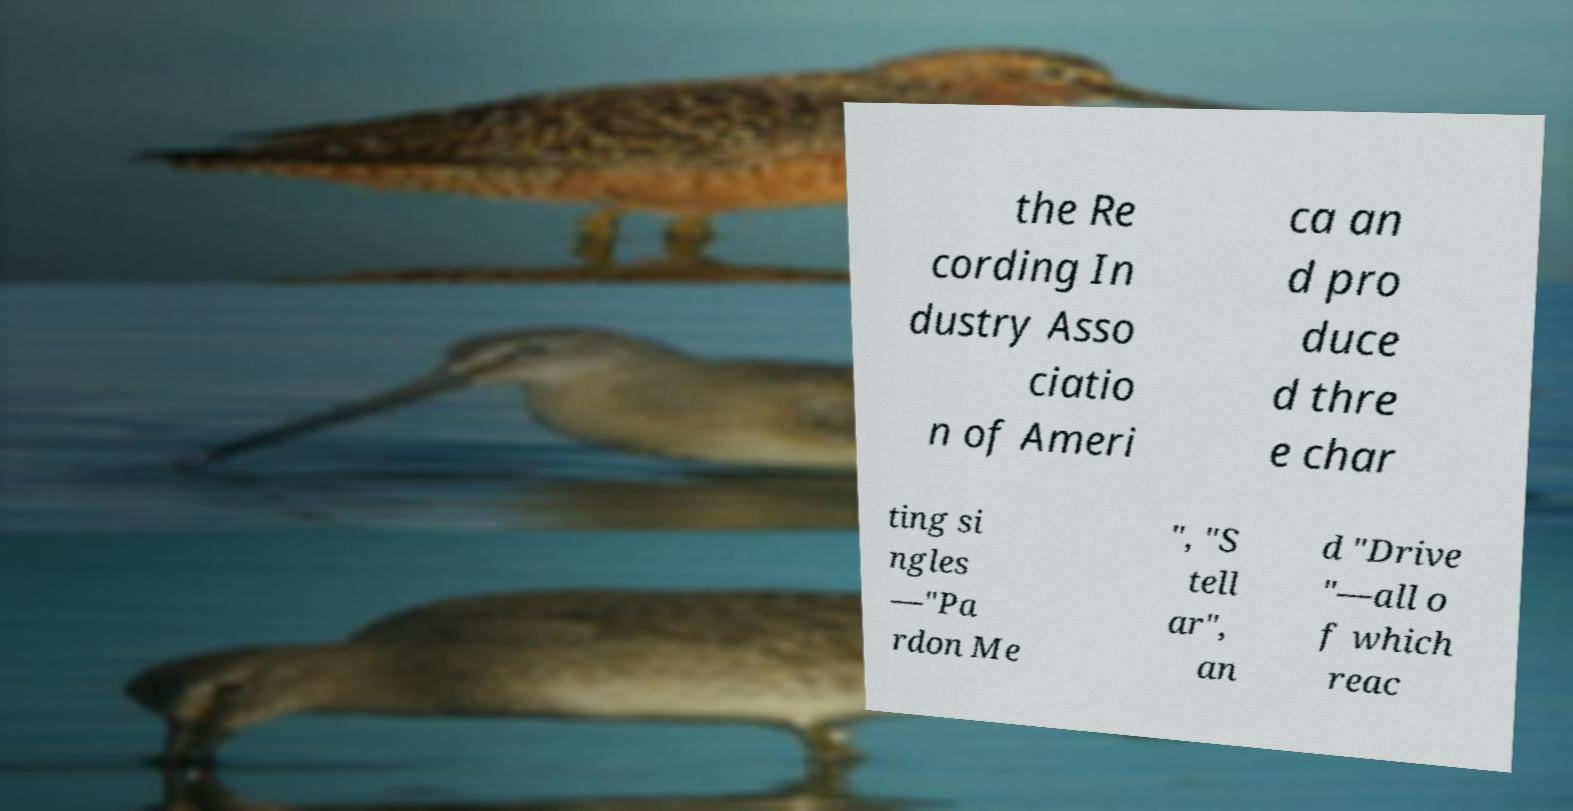For documentation purposes, I need the text within this image transcribed. Could you provide that? the Re cording In dustry Asso ciatio n of Ameri ca an d pro duce d thre e char ting si ngles —"Pa rdon Me ", "S tell ar", an d "Drive "—all o f which reac 